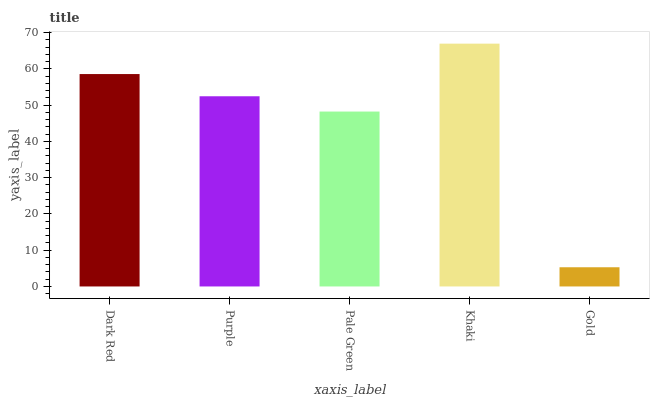Is Gold the minimum?
Answer yes or no. Yes. Is Khaki the maximum?
Answer yes or no. Yes. Is Purple the minimum?
Answer yes or no. No. Is Purple the maximum?
Answer yes or no. No. Is Dark Red greater than Purple?
Answer yes or no. Yes. Is Purple less than Dark Red?
Answer yes or no. Yes. Is Purple greater than Dark Red?
Answer yes or no. No. Is Dark Red less than Purple?
Answer yes or no. No. Is Purple the high median?
Answer yes or no. Yes. Is Purple the low median?
Answer yes or no. Yes. Is Khaki the high median?
Answer yes or no. No. Is Dark Red the low median?
Answer yes or no. No. 